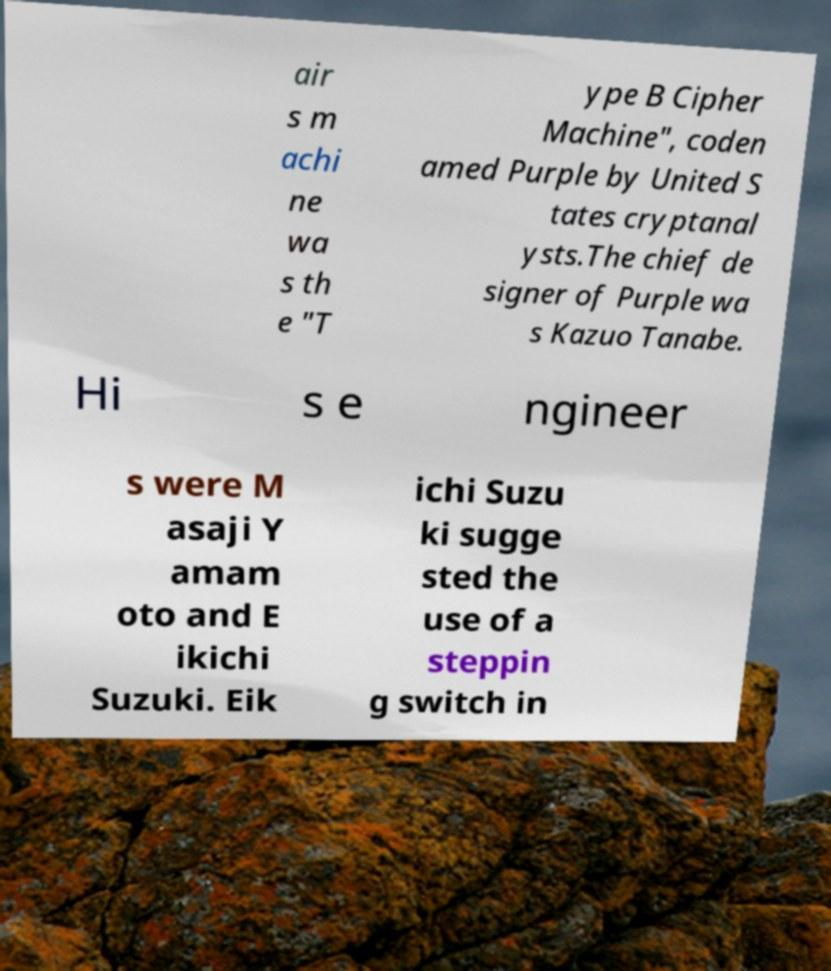Can you read and provide the text displayed in the image?This photo seems to have some interesting text. Can you extract and type it out for me? air s m achi ne wa s th e "T ype B Cipher Machine", coden amed Purple by United S tates cryptanal ysts.The chief de signer of Purple wa s Kazuo Tanabe. Hi s e ngineer s were M asaji Y amam oto and E ikichi Suzuki. Eik ichi Suzu ki sugge sted the use of a steppin g switch in 